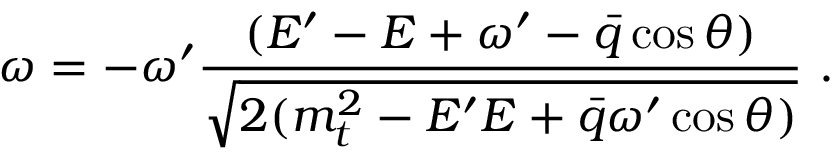<formula> <loc_0><loc_0><loc_500><loc_500>\omega = - \omega ^ { \prime } \frac { ( E ^ { \prime } - E + \omega ^ { \prime } - \bar { q } \cos \theta ) } { \sqrt { 2 ( m _ { t } ^ { 2 } - E ^ { \prime } E + \bar { q } \omega ^ { \prime } \cos \theta ) } } \ .</formula> 